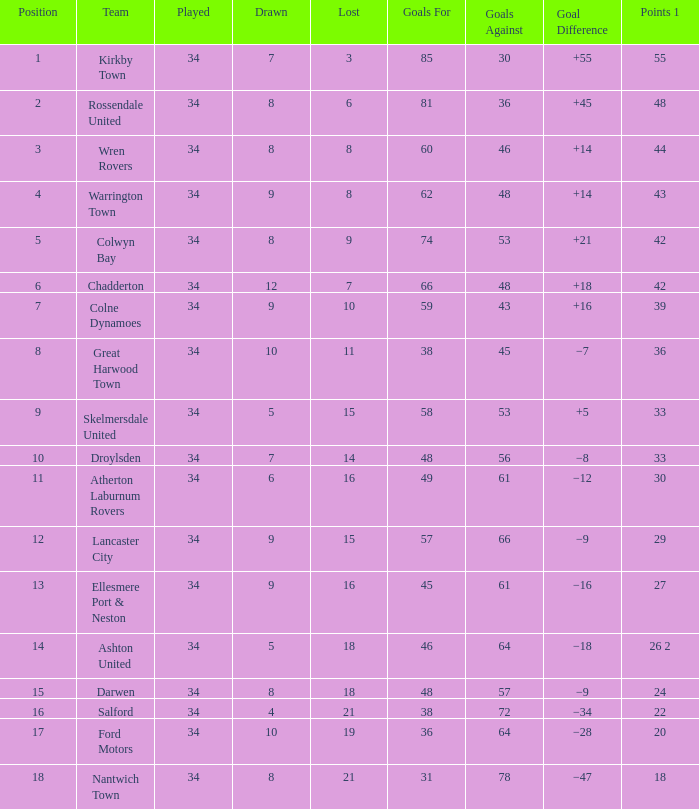What is the minimum number of goals conceded when 8 matches were lost and 60 goals were scored? 46.0. 